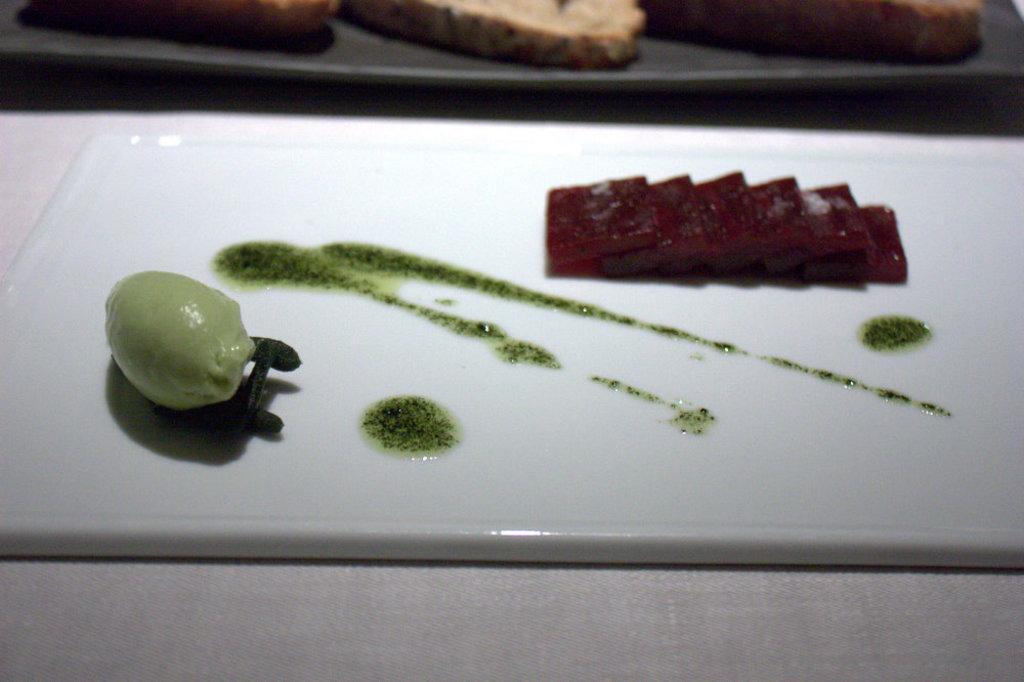Describe this image in one or two sentences. In this image there are a few food items on a chopping board, the chopping board is on top of a table. 